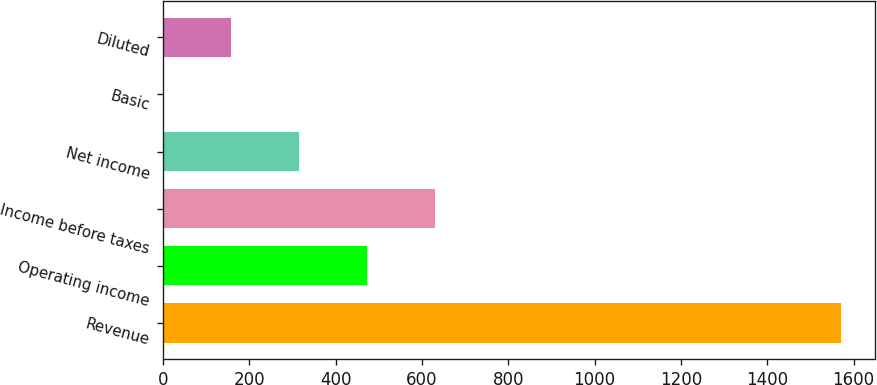Convert chart. <chart><loc_0><loc_0><loc_500><loc_500><bar_chart><fcel>Revenue<fcel>Operating income<fcel>Income before taxes<fcel>Net income<fcel>Basic<fcel>Diluted<nl><fcel>1571.7<fcel>472.36<fcel>629.41<fcel>315.31<fcel>1.21<fcel>158.26<nl></chart> 